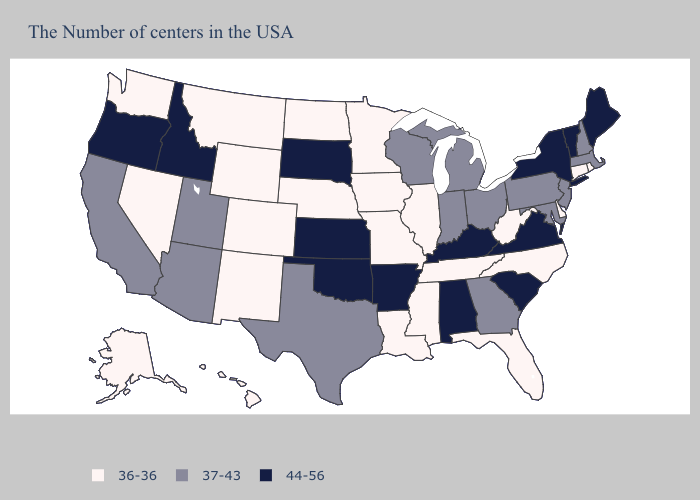Does Massachusetts have the lowest value in the USA?
Answer briefly. No. Which states hav the highest value in the Northeast?
Short answer required. Maine, Vermont, New York. Name the states that have a value in the range 36-36?
Keep it brief. Rhode Island, Connecticut, Delaware, North Carolina, West Virginia, Florida, Tennessee, Illinois, Mississippi, Louisiana, Missouri, Minnesota, Iowa, Nebraska, North Dakota, Wyoming, Colorado, New Mexico, Montana, Nevada, Washington, Alaska, Hawaii. Does Pennsylvania have a lower value than South Dakota?
Give a very brief answer. Yes. What is the value of Washington?
Give a very brief answer. 36-36. What is the lowest value in states that border South Dakota?
Concise answer only. 36-36. What is the value of Alabama?
Write a very short answer. 44-56. Name the states that have a value in the range 44-56?
Concise answer only. Maine, Vermont, New York, Virginia, South Carolina, Kentucky, Alabama, Arkansas, Kansas, Oklahoma, South Dakota, Idaho, Oregon. What is the highest value in the MidWest ?
Short answer required. 44-56. Name the states that have a value in the range 44-56?
Quick response, please. Maine, Vermont, New York, Virginia, South Carolina, Kentucky, Alabama, Arkansas, Kansas, Oklahoma, South Dakota, Idaho, Oregon. Which states have the highest value in the USA?
Concise answer only. Maine, Vermont, New York, Virginia, South Carolina, Kentucky, Alabama, Arkansas, Kansas, Oklahoma, South Dakota, Idaho, Oregon. What is the value of Montana?
Short answer required. 36-36. Among the states that border South Dakota , which have the highest value?
Concise answer only. Minnesota, Iowa, Nebraska, North Dakota, Wyoming, Montana. Is the legend a continuous bar?
Concise answer only. No. What is the highest value in states that border Kentucky?
Concise answer only. 44-56. 